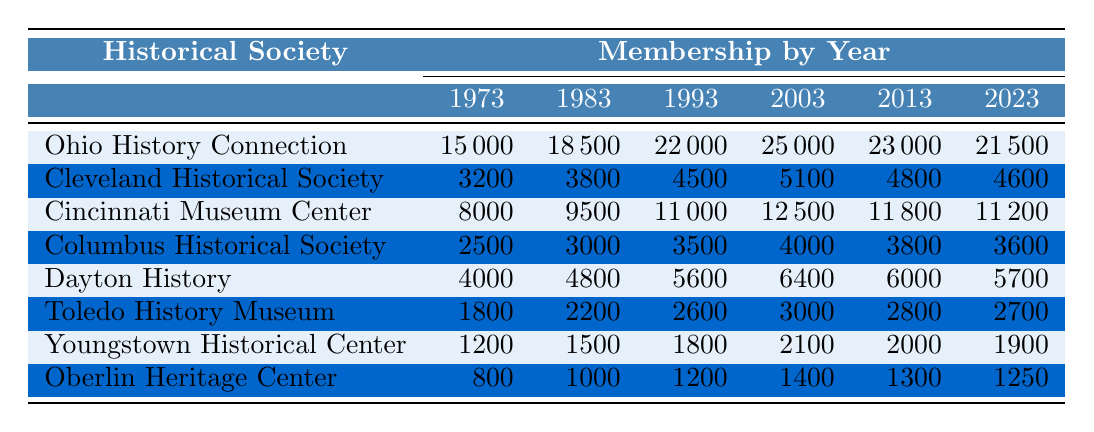What is the membership count of the Ohio History Connection in 2023? According to the table, the membership count for the Ohio History Connection in 2023 is listed directly as 21,500.
Answer: 21,500 Which historical society had the highest membership in 2003? Looking at the membership counts for the year 2003, the Ohio History Connection has the highest membership at 25,000 compared to the other societies.
Answer: Ohio History Connection What was the percentage decrease in membership for the Cleveland Historical Society from 2003 to 2023? From 2003 to 2023, the Cleveland Historical Society had 5,100 members in 2003 and 4,600 members in 2023. The decrease is 5,100 - 4,600 = 500. The percentage decrease is (500 / 5,100) * 100 = 9.8%.
Answer: 9.8% What was the average membership for Dayton History over the 50 years? The membership counts for Dayton History are 4,000, 4,800, 5,600, 6,400, 6,000, and 5,700. Summing these numbers gives 4,000 + 4,800 + 5,600 + 6,400 + 6,000 + 5,700 = 32,500. Dividing by 6 (the number of years) gives an average of 32,500 / 6 ≈ 5,417.
Answer: 5,417 Is the membership trend for the Oberlin Heritage Center increasing or decreasing over the years? The membership counts for Oberlin Heritage Center were 800, 1,000, 1,200, 1,400, 1,300, and 1,250. The peak was in 2003 with 1,400 members, followed by a decrease in the subsequent years. Thus, the trend is decreasing.
Answer: Decreasing Which society experienced a drop in membership from 2013 to 2023, and what was the specific drop for that society? Observing the table, the membership counts for various societies show that Ohio History Connection dropped from 23,000 to 21,500 (1,500 drop), Cleveland Historical Society from 4,800 to 4,600 (200 drop), Cincinnati Museum Center from 11,800 to 11,200 (600 drop), Columbus Historical Society from 3,800 to 3,600 (200 drop), Dayton History from 6,000 to 5,700 (300 drop), Toledo History Museum from 2,800 to 2,700 (100 drop), Youngstown Historical Center from 2,000 to 1,900 (100 drop), and Oberlin Heritage Center from 1,300 to 1,250 (50 drop). All societies except for them experienced drops in memberships.
Answer: All societies dropped in membership Which society had the most consistent growth over the periods observed? By reviewing the changes in membership for each society over the years, the Cincinnati Museum Center shows a consistent upward trajectory until 2013 and only a slight decline in the last two periods. The memberships in 1973 to 2013 are steadily increasing: 8,000, 9,500, 11,000, 12,500, and 11,800, resulting in fewer fluctuations than other societies.
Answer: Cincinnati Museum Center 